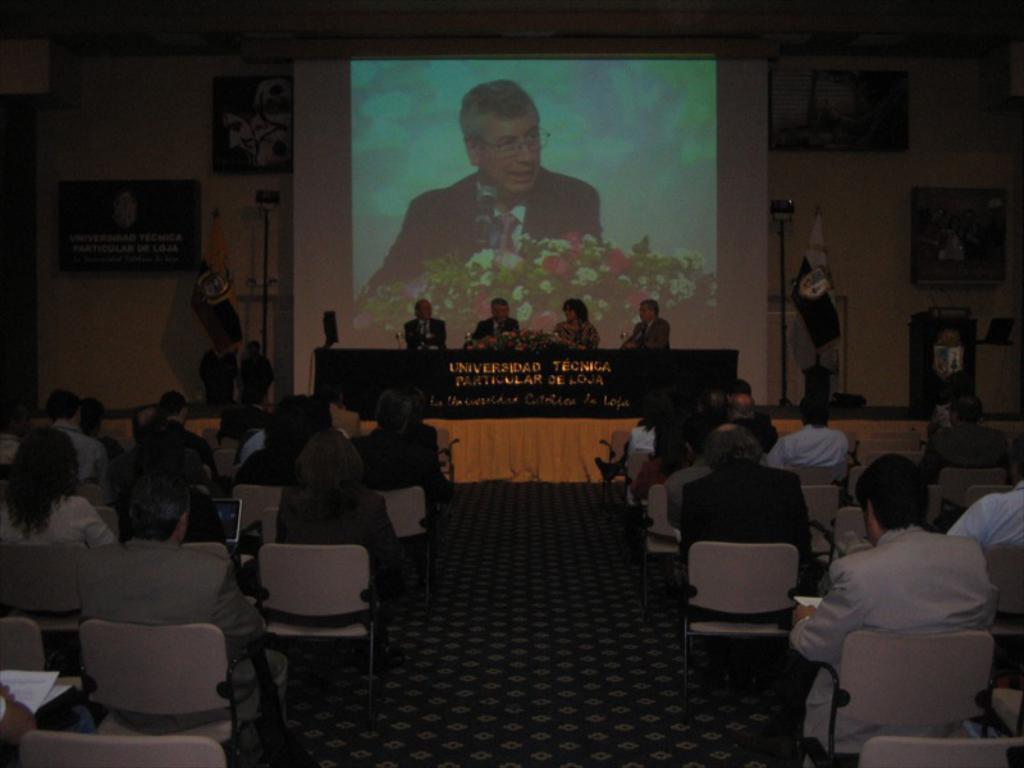Could you give a brief overview of what you see in this image? In this image there are group of people siting on the chair. At the back side we can see a screen. The boards are attached to the wall and there is a flag. 